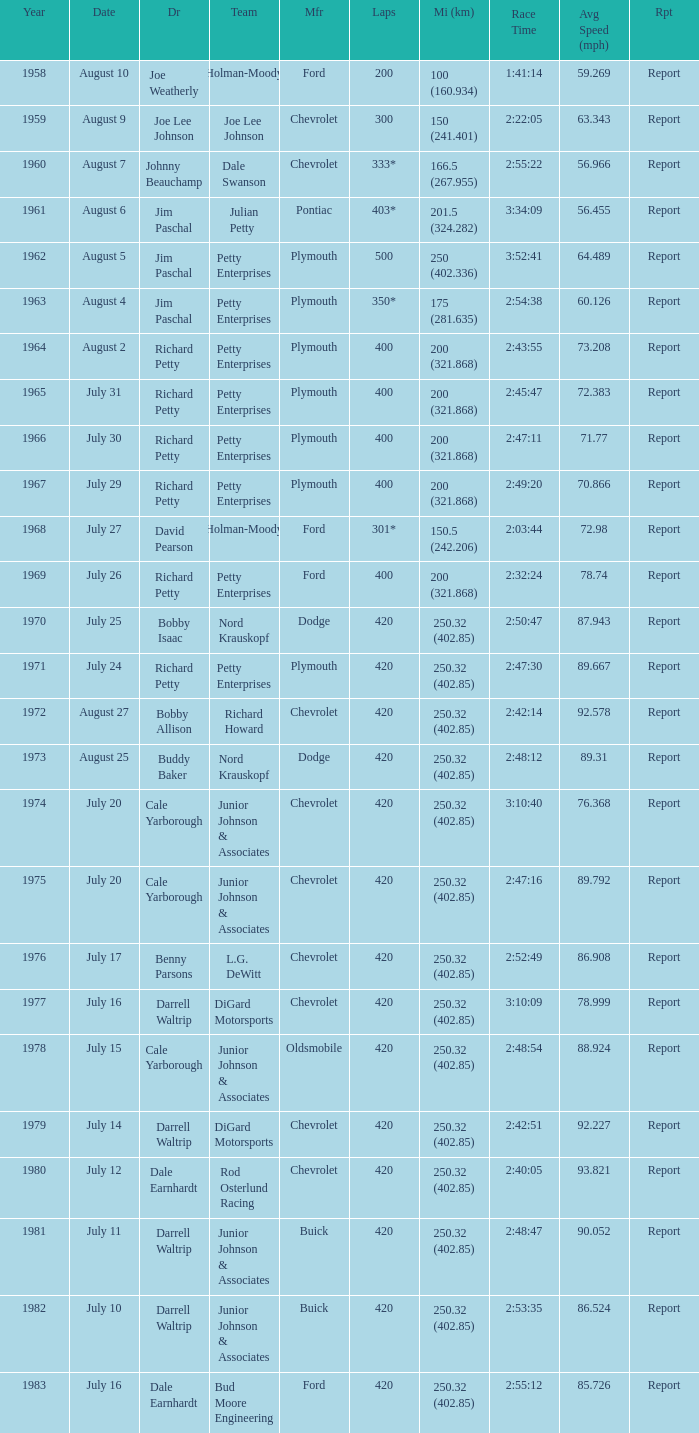How many miles were driven in the race where the winner finished in 2:47:11? 200 (321.868). Give me the full table as a dictionary. {'header': ['Year', 'Date', 'Dr', 'Team', 'Mfr', 'Laps', 'Mi (km)', 'Race Time', 'Avg Speed (mph)', 'Rpt'], 'rows': [['1958', 'August 10', 'Joe Weatherly', 'Holman-Moody', 'Ford', '200', '100 (160.934)', '1:41:14', '59.269', 'Report'], ['1959', 'August 9', 'Joe Lee Johnson', 'Joe Lee Johnson', 'Chevrolet', '300', '150 (241.401)', '2:22:05', '63.343', 'Report'], ['1960', 'August 7', 'Johnny Beauchamp', 'Dale Swanson', 'Chevrolet', '333*', '166.5 (267.955)', '2:55:22', '56.966', 'Report'], ['1961', 'August 6', 'Jim Paschal', 'Julian Petty', 'Pontiac', '403*', '201.5 (324.282)', '3:34:09', '56.455', 'Report'], ['1962', 'August 5', 'Jim Paschal', 'Petty Enterprises', 'Plymouth', '500', '250 (402.336)', '3:52:41', '64.489', 'Report'], ['1963', 'August 4', 'Jim Paschal', 'Petty Enterprises', 'Plymouth', '350*', '175 (281.635)', '2:54:38', '60.126', 'Report'], ['1964', 'August 2', 'Richard Petty', 'Petty Enterprises', 'Plymouth', '400', '200 (321.868)', '2:43:55', '73.208', 'Report'], ['1965', 'July 31', 'Richard Petty', 'Petty Enterprises', 'Plymouth', '400', '200 (321.868)', '2:45:47', '72.383', 'Report'], ['1966', 'July 30', 'Richard Petty', 'Petty Enterprises', 'Plymouth', '400', '200 (321.868)', '2:47:11', '71.77', 'Report'], ['1967', 'July 29', 'Richard Petty', 'Petty Enterprises', 'Plymouth', '400', '200 (321.868)', '2:49:20', '70.866', 'Report'], ['1968', 'July 27', 'David Pearson', 'Holman-Moody', 'Ford', '301*', '150.5 (242.206)', '2:03:44', '72.98', 'Report'], ['1969', 'July 26', 'Richard Petty', 'Petty Enterprises', 'Ford', '400', '200 (321.868)', '2:32:24', '78.74', 'Report'], ['1970', 'July 25', 'Bobby Isaac', 'Nord Krauskopf', 'Dodge', '420', '250.32 (402.85)', '2:50:47', '87.943', 'Report'], ['1971', 'July 24', 'Richard Petty', 'Petty Enterprises', 'Plymouth', '420', '250.32 (402.85)', '2:47:30', '89.667', 'Report'], ['1972', 'August 27', 'Bobby Allison', 'Richard Howard', 'Chevrolet', '420', '250.32 (402.85)', '2:42:14', '92.578', 'Report'], ['1973', 'August 25', 'Buddy Baker', 'Nord Krauskopf', 'Dodge', '420', '250.32 (402.85)', '2:48:12', '89.31', 'Report'], ['1974', 'July 20', 'Cale Yarborough', 'Junior Johnson & Associates', 'Chevrolet', '420', '250.32 (402.85)', '3:10:40', '76.368', 'Report'], ['1975', 'July 20', 'Cale Yarborough', 'Junior Johnson & Associates', 'Chevrolet', '420', '250.32 (402.85)', '2:47:16', '89.792', 'Report'], ['1976', 'July 17', 'Benny Parsons', 'L.G. DeWitt', 'Chevrolet', '420', '250.32 (402.85)', '2:52:49', '86.908', 'Report'], ['1977', 'July 16', 'Darrell Waltrip', 'DiGard Motorsports', 'Chevrolet', '420', '250.32 (402.85)', '3:10:09', '78.999', 'Report'], ['1978', 'July 15', 'Cale Yarborough', 'Junior Johnson & Associates', 'Oldsmobile', '420', '250.32 (402.85)', '2:48:54', '88.924', 'Report'], ['1979', 'July 14', 'Darrell Waltrip', 'DiGard Motorsports', 'Chevrolet', '420', '250.32 (402.85)', '2:42:51', '92.227', 'Report'], ['1980', 'July 12', 'Dale Earnhardt', 'Rod Osterlund Racing', 'Chevrolet', '420', '250.32 (402.85)', '2:40:05', '93.821', 'Report'], ['1981', 'July 11', 'Darrell Waltrip', 'Junior Johnson & Associates', 'Buick', '420', '250.32 (402.85)', '2:48:47', '90.052', 'Report'], ['1982', 'July 10', 'Darrell Waltrip', 'Junior Johnson & Associates', 'Buick', '420', '250.32 (402.85)', '2:53:35', '86.524', 'Report'], ['1983', 'July 16', 'Dale Earnhardt', 'Bud Moore Engineering', 'Ford', '420', '250.32 (402.85)', '2:55:12', '85.726', 'Report']]} 